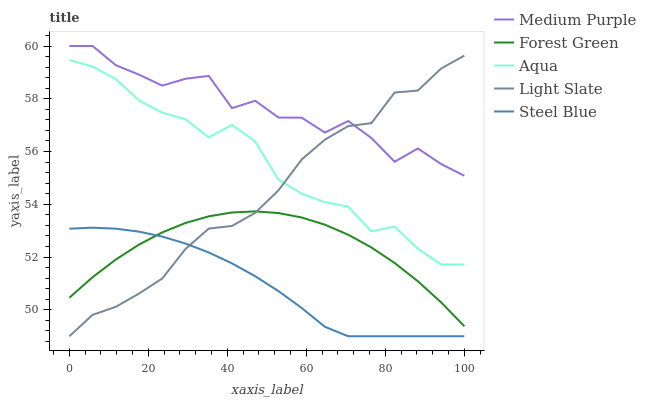Does Steel Blue have the minimum area under the curve?
Answer yes or no. Yes. Does Medium Purple have the maximum area under the curve?
Answer yes or no. Yes. Does Light Slate have the minimum area under the curve?
Answer yes or no. No. Does Light Slate have the maximum area under the curve?
Answer yes or no. No. Is Steel Blue the smoothest?
Answer yes or no. Yes. Is Medium Purple the roughest?
Answer yes or no. Yes. Is Light Slate the smoothest?
Answer yes or no. No. Is Light Slate the roughest?
Answer yes or no. No. Does Light Slate have the lowest value?
Answer yes or no. Yes. Does Forest Green have the lowest value?
Answer yes or no. No. Does Medium Purple have the highest value?
Answer yes or no. Yes. Does Light Slate have the highest value?
Answer yes or no. No. Is Forest Green less than Medium Purple?
Answer yes or no. Yes. Is Aqua greater than Forest Green?
Answer yes or no. Yes. Does Medium Purple intersect Light Slate?
Answer yes or no. Yes. Is Medium Purple less than Light Slate?
Answer yes or no. No. Is Medium Purple greater than Light Slate?
Answer yes or no. No. Does Forest Green intersect Medium Purple?
Answer yes or no. No. 